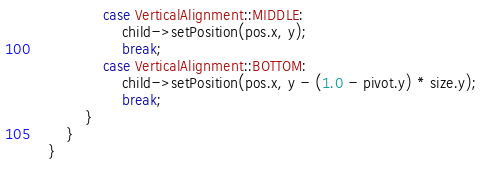Convert code to text. <code><loc_0><loc_0><loc_500><loc_500><_C++_>				case VerticalAlignment::MIDDLE:
					child->setPosition(pos.x, y);
					break;
				case VerticalAlignment::BOTTOM:
					child->setPosition(pos.x, y - (1.0 - pivot.y) * size.y);
					break;
			}
		}
	}
	</code> 